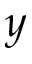Convert formula to latex. <formula><loc_0><loc_0><loc_500><loc_500>y</formula> 